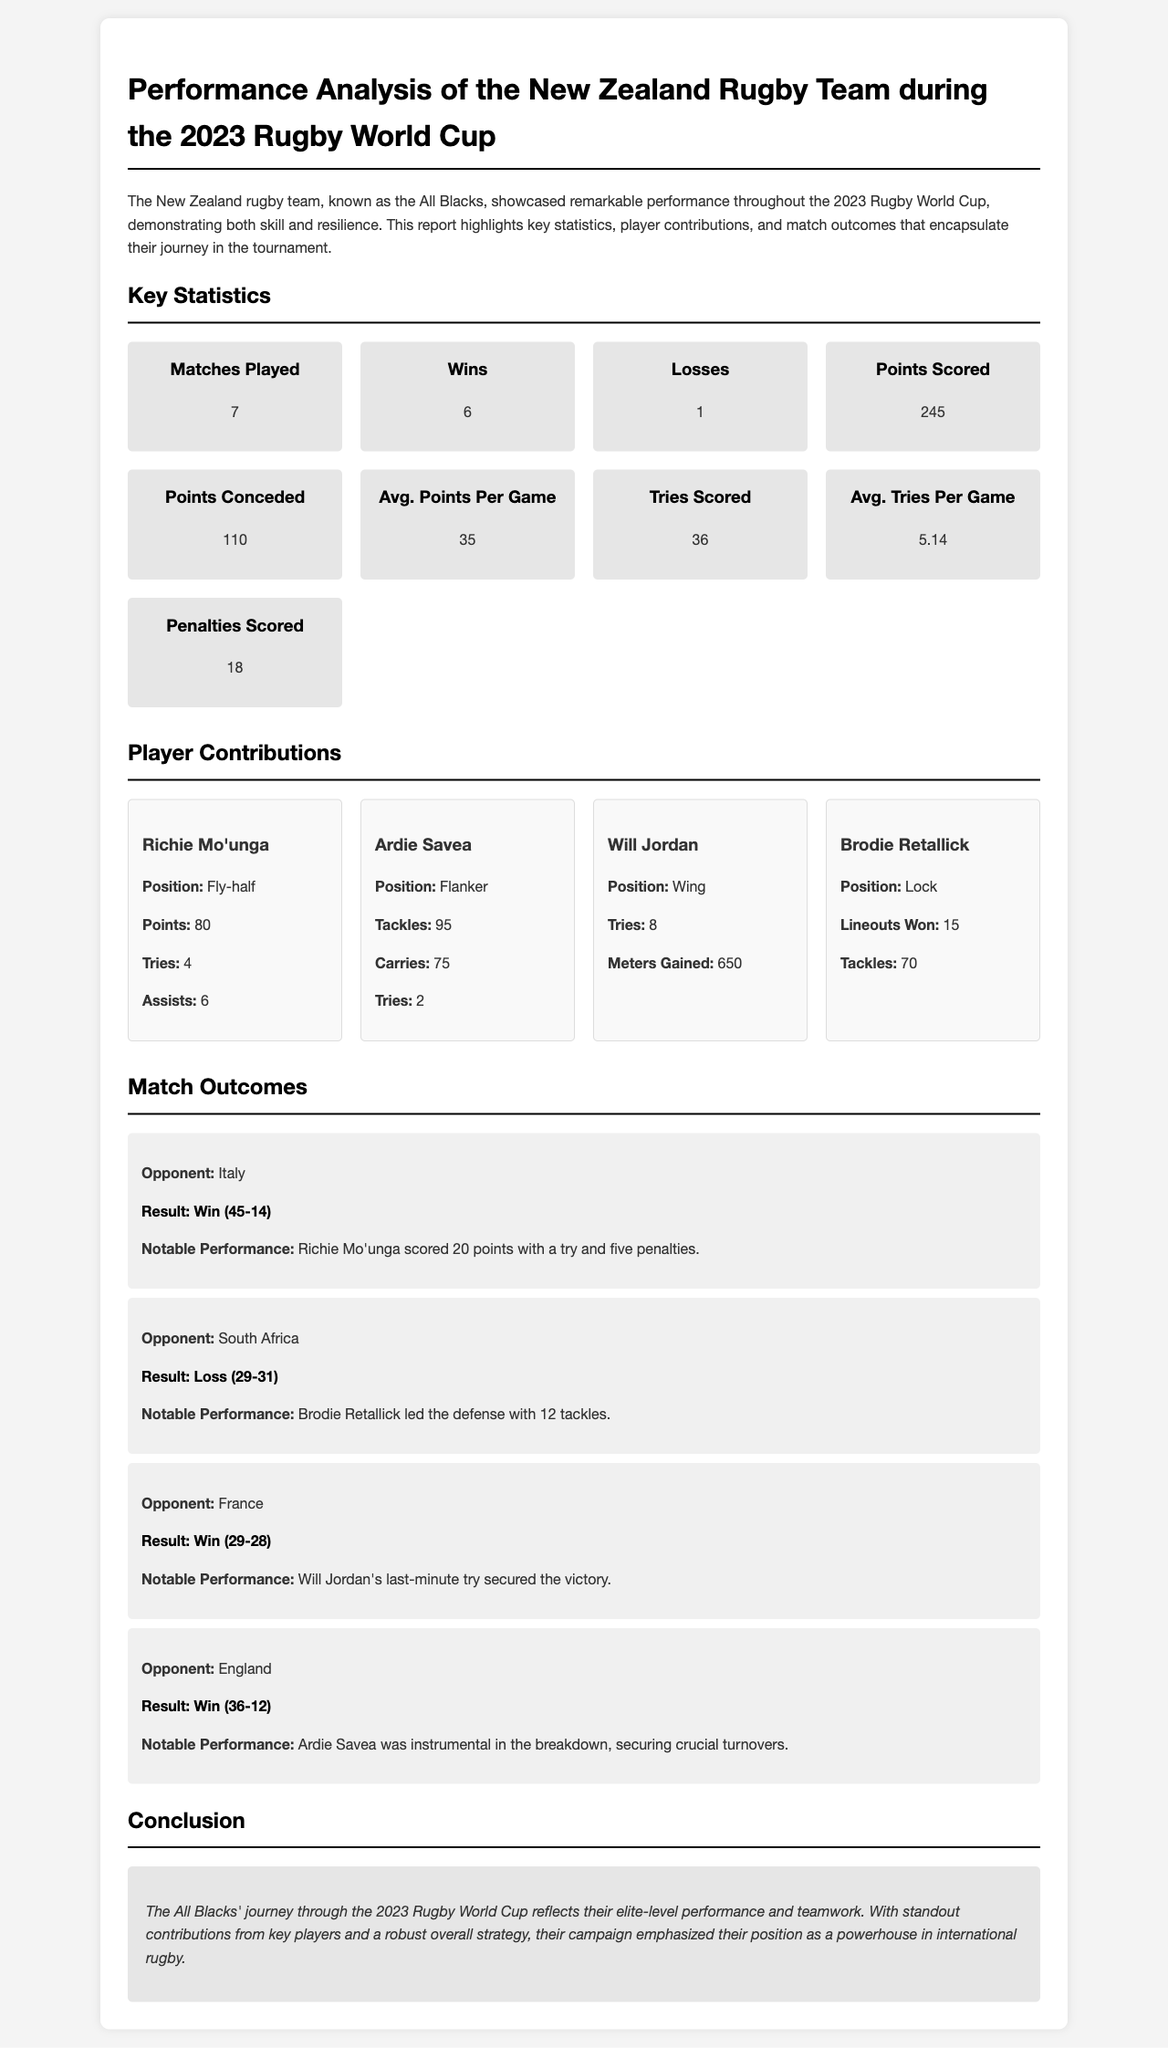What was the headline of the report? The headline provides an overview of the document's content, which is about the performance analysis of the New Zealand rugby team during the tournament.
Answer: Performance Analysis of the New Zealand Rugby Team during the 2023 Rugby World Cup How many matches did the All Blacks play? The total number of matches played is listed in the key statistics section of the document.
Answer: 7 Who scored the most points for the team? The player who scored the most points is mentioned in the player contributions section.
Answer: Richie Mo'unga What was the result of the match against South Africa? The outcome of the match versus South Africa is specified in the match outcomes section.
Answer: Loss (29-31) Which player had the most tackles? The player with the highest number of tackles is noted in the player contributions section of the report.
Answer: Ardie Savea How many points were scored by the All Blacks in total? The total points scored by the All Blacks is provided in the key statistics section.
Answer: 245 What position did Will Jordan play? The position of Will Jordan is stated in his player contribution details.
Answer: Wing What was the conclusion of the report? The conclusion summarizes the overall performance and contributions reflected in the tournament.
Answer: The All Blacks' journey through the 2023 Rugby World Cup reflects their elite-level performance and teamwork 